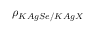Convert formula to latex. <formula><loc_0><loc_0><loc_500><loc_500>\rho _ { K A g S e / K A g X }</formula> 